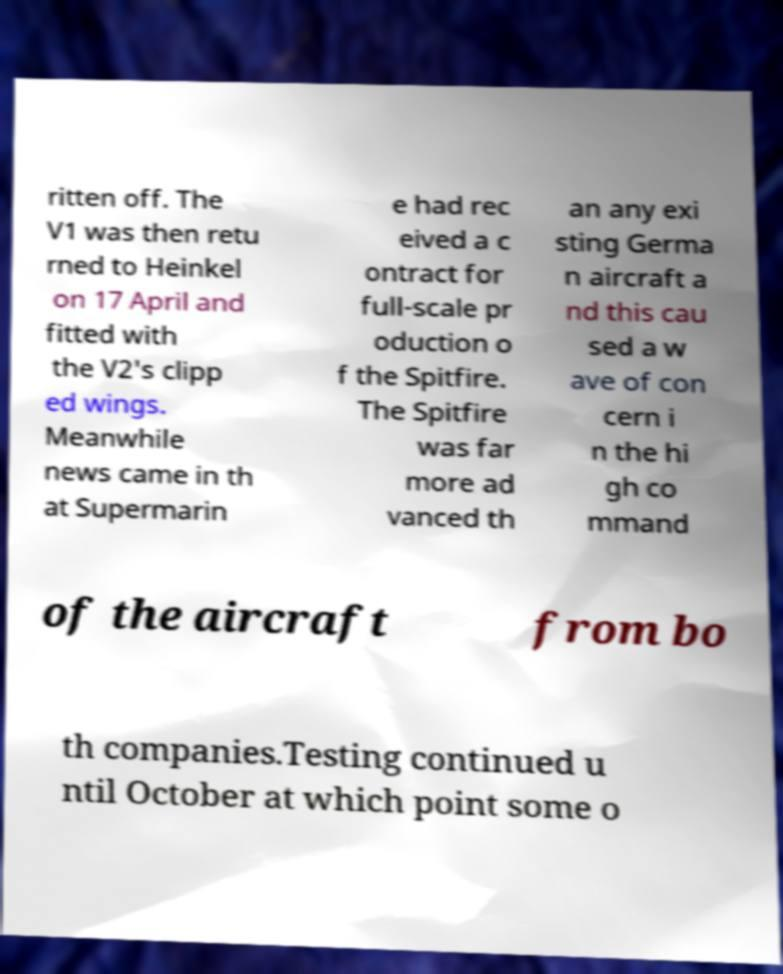Could you assist in decoding the text presented in this image and type it out clearly? ritten off. The V1 was then retu rned to Heinkel on 17 April and fitted with the V2's clipp ed wings. Meanwhile news came in th at Supermarin e had rec eived a c ontract for full-scale pr oduction o f the Spitfire. The Spitfire was far more ad vanced th an any exi sting Germa n aircraft a nd this cau sed a w ave of con cern i n the hi gh co mmand of the aircraft from bo th companies.Testing continued u ntil October at which point some o 